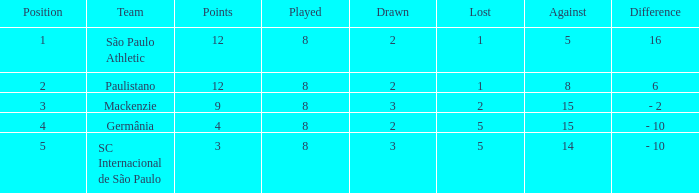In which position was the entire quantity less than 1? 0.0. 